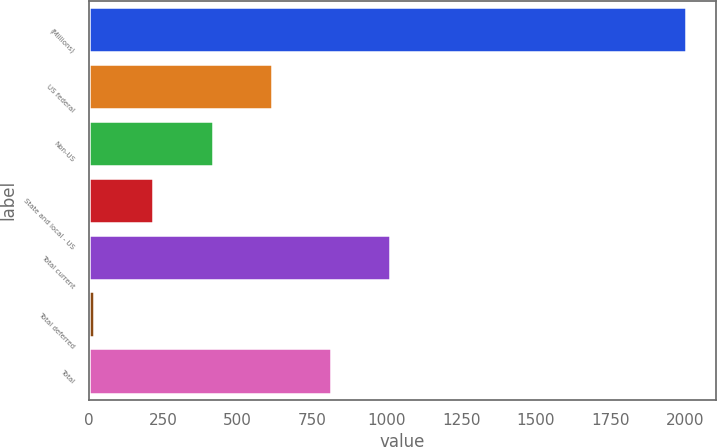<chart> <loc_0><loc_0><loc_500><loc_500><bar_chart><fcel>(Millions)<fcel>US federal<fcel>Non-US<fcel>State and local - US<fcel>Total current<fcel>Total deferred<fcel>Total<nl><fcel>2004<fcel>614.5<fcel>416<fcel>217.5<fcel>1011.5<fcel>19<fcel>813<nl></chart> 